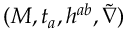<formula> <loc_0><loc_0><loc_500><loc_500>( M , t _ { a } , h ^ { a b } , \tilde { \nabla } )</formula> 